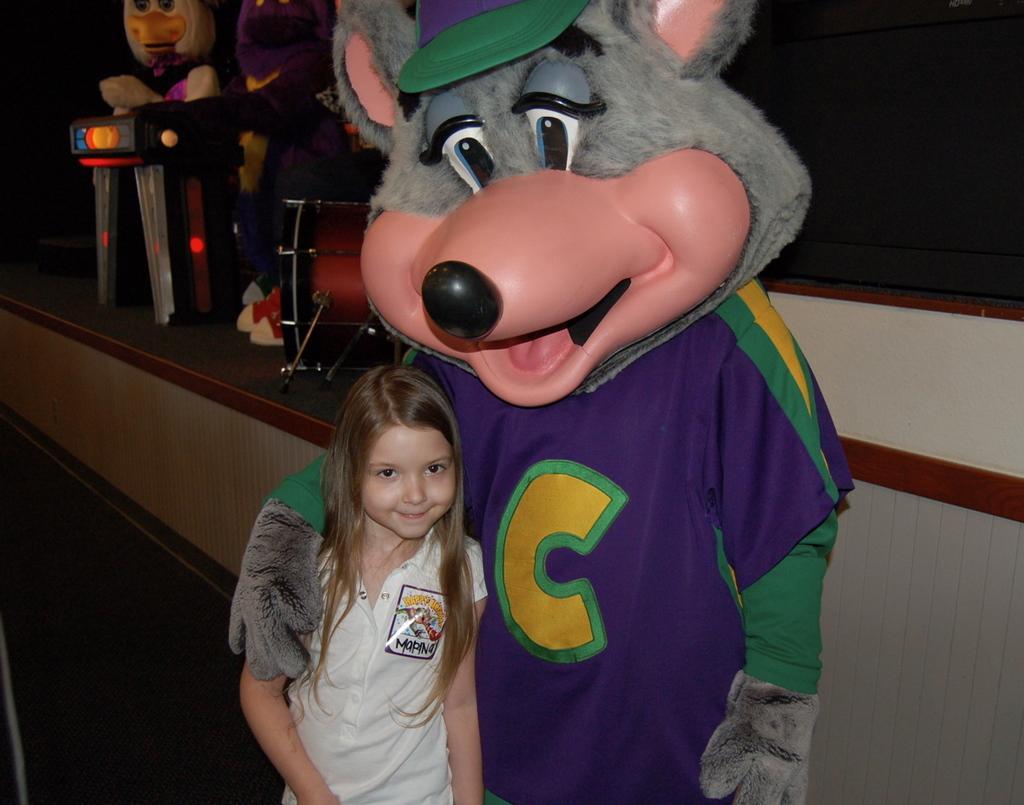How would you summarize this image in a sentence or two? In this image there are few persons wearing costumes and a girl standing, in the background there is a stage, on that stage there are musical instruments. 